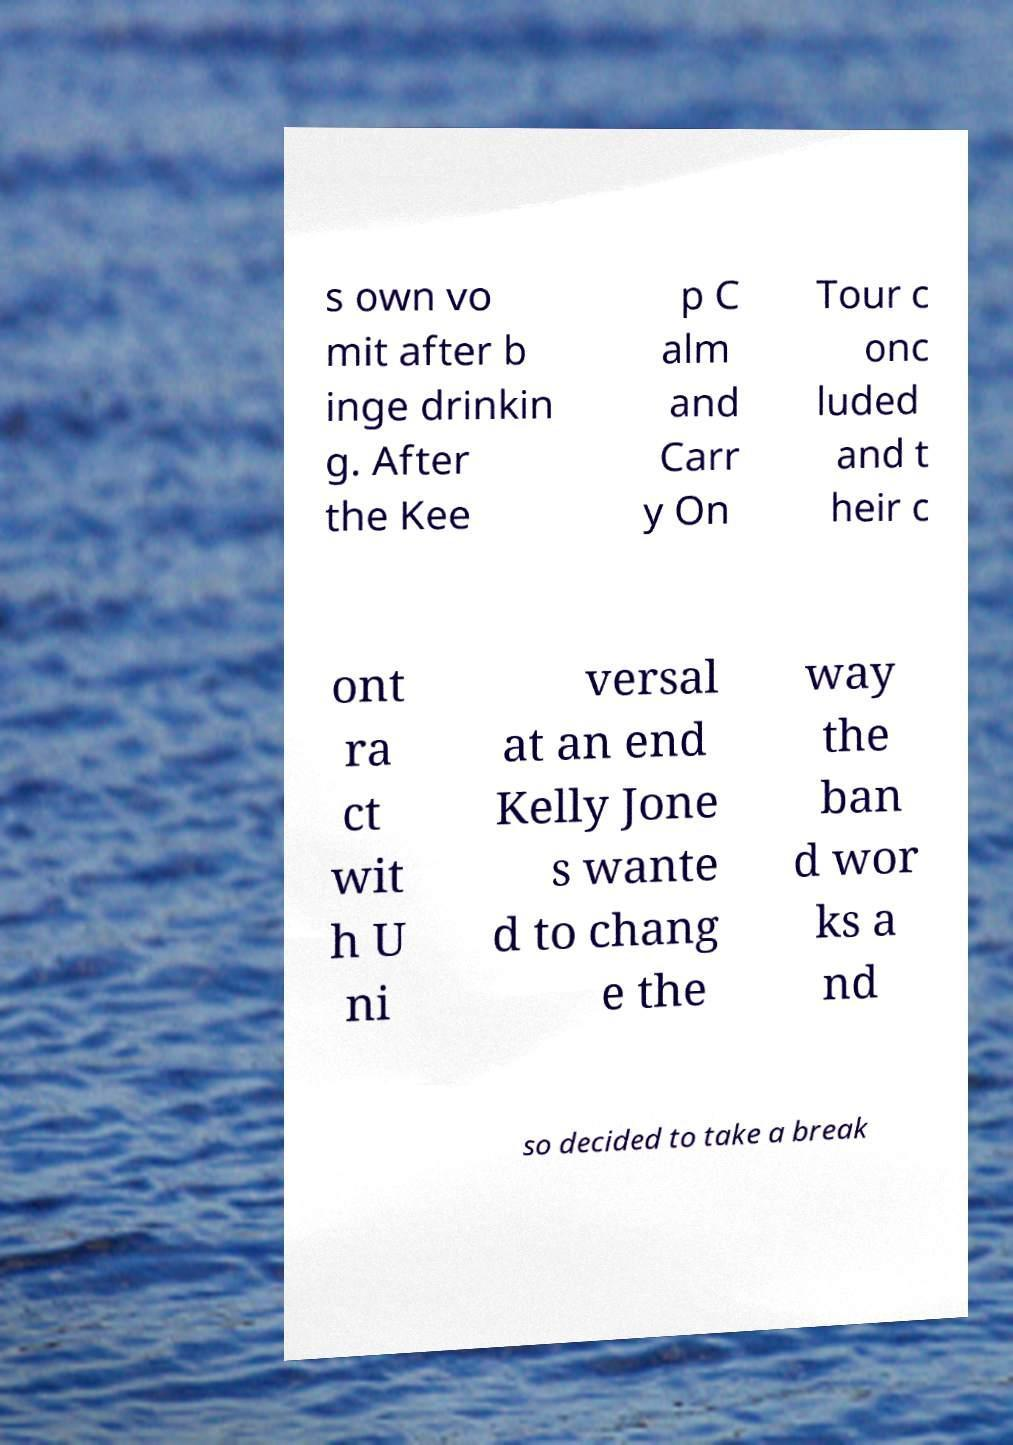Can you read and provide the text displayed in the image?This photo seems to have some interesting text. Can you extract and type it out for me? s own vo mit after b inge drinkin g. After the Kee p C alm and Carr y On Tour c onc luded and t heir c ont ra ct wit h U ni versal at an end Kelly Jone s wante d to chang e the way the ban d wor ks a nd so decided to take a break 